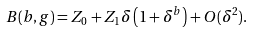<formula> <loc_0><loc_0><loc_500><loc_500>B ( b , g ) = Z _ { 0 } + Z _ { 1 } \delta \left ( 1 + \delta ^ { b } \right ) + O ( \delta ^ { 2 } ) .</formula> 